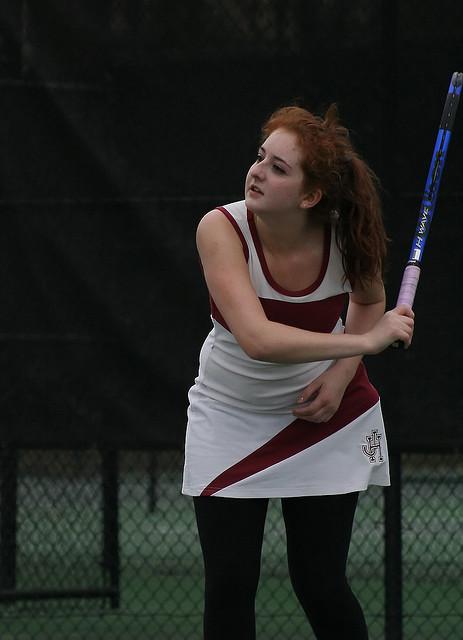Is the girl a professional?
Write a very short answer. Yes. What vegetable is used to describe this woman's hair?
Be succinct. Carrot. What sport is this girl playing?
Keep it brief. Tennis. What is the woman holding?
Write a very short answer. Racket. What color is the baseball bat?
Quick response, please. Blue. What color dress is the woman wearing?
Write a very short answer. White and red. What is the woman doing?
Quick response, please. Playing tennis. What brand is the racket?
Concise answer only. Unknown. What gender is the person in this picture?
Write a very short answer. Female. Is this woman trying hard?
Quick response, please. No. Would this woman be considered Caucasian?
Be succinct. Yes. Is this player in uniform?
Answer briefly. Yes. 